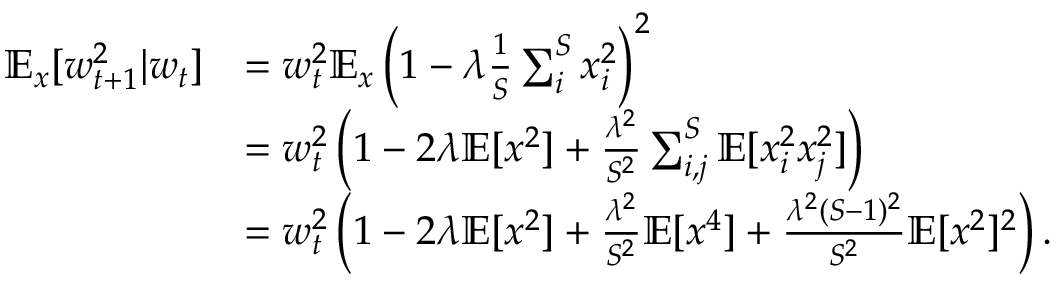<formula> <loc_0><loc_0><loc_500><loc_500>\begin{array} { r l } { \mathbb { E } _ { x } [ w _ { t + 1 } ^ { 2 } | w _ { t } ] } & { = w _ { t } ^ { 2 } \mathbb { E } _ { x } \left ( 1 - \lambda \frac { 1 } { S } \sum _ { i } ^ { S } x _ { i } ^ { 2 } \right ) ^ { 2 } } \\ & { = w _ { t } ^ { 2 } \left ( 1 - 2 \lambda \mathbb { E } [ x ^ { 2 } ] + \frac { \lambda ^ { 2 } } { S ^ { 2 } } \sum _ { i , j } ^ { S } \mathbb { E } [ x _ { i } ^ { 2 } x _ { j } ^ { 2 } ] \right ) } \\ & { = w _ { t } ^ { 2 } \left ( 1 - 2 \lambda \mathbb { E } [ x ^ { 2 } ] + \frac { \lambda ^ { 2 } } { S ^ { 2 } } \mathbb { E } [ x ^ { 4 } ] + \frac { \lambda ^ { 2 } ( S - 1 ) ^ { 2 } } { S ^ { 2 } } \mathbb { E } [ x ^ { 2 } ] ^ { 2 } \right ) . } \end{array}</formula> 